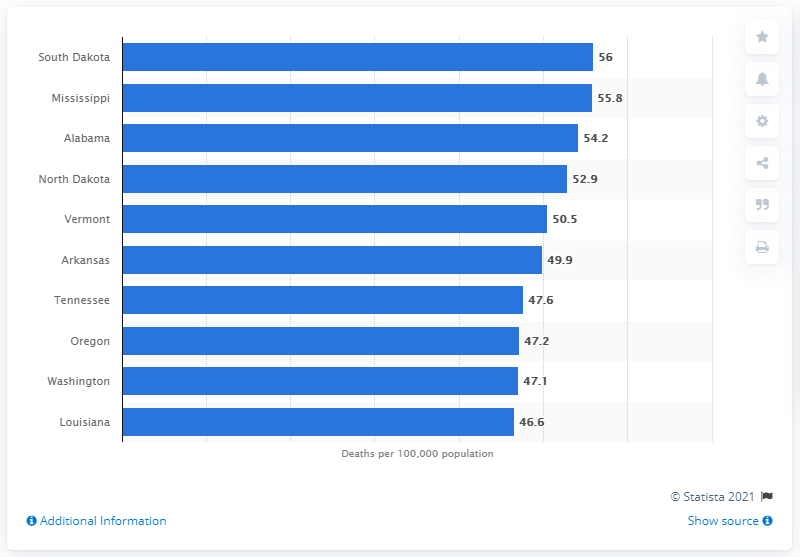Highlight a few significant elements in this photo. In 2016, the state with the highest Alzheimer's mortality rate was Mississippi. 